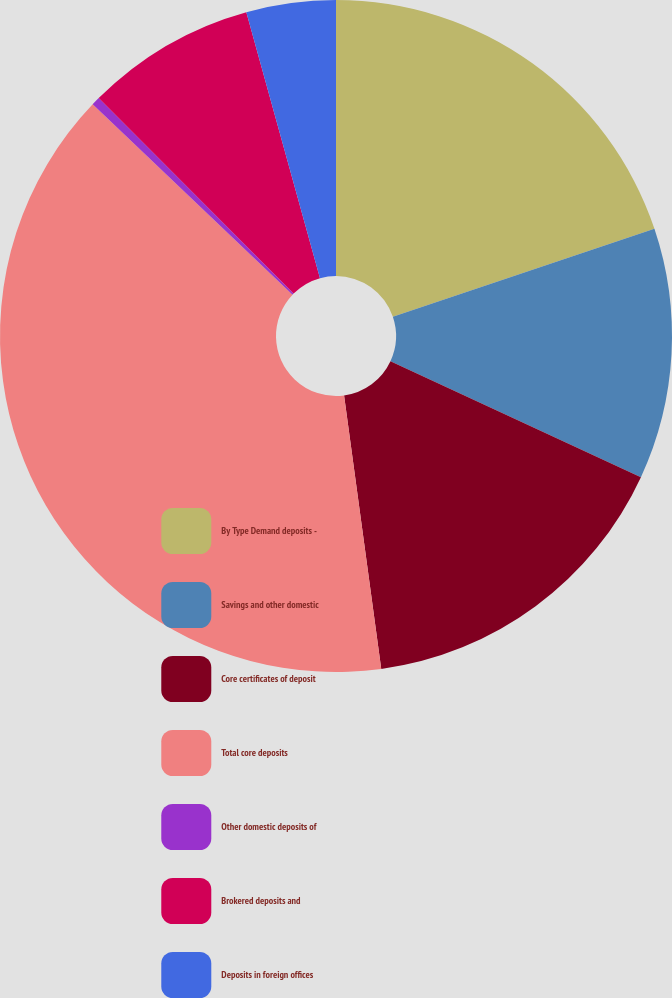Convert chart to OTSL. <chart><loc_0><loc_0><loc_500><loc_500><pie_chart><fcel>By Type Demand deposits -<fcel>Savings and other domestic<fcel>Core certificates of deposit<fcel>Total core deposits<fcel>Other domestic deposits of<fcel>Brokered deposits and<fcel>Deposits in foreign offices<nl><fcel>19.83%<fcel>12.07%<fcel>15.95%<fcel>39.26%<fcel>0.41%<fcel>8.18%<fcel>4.3%<nl></chart> 